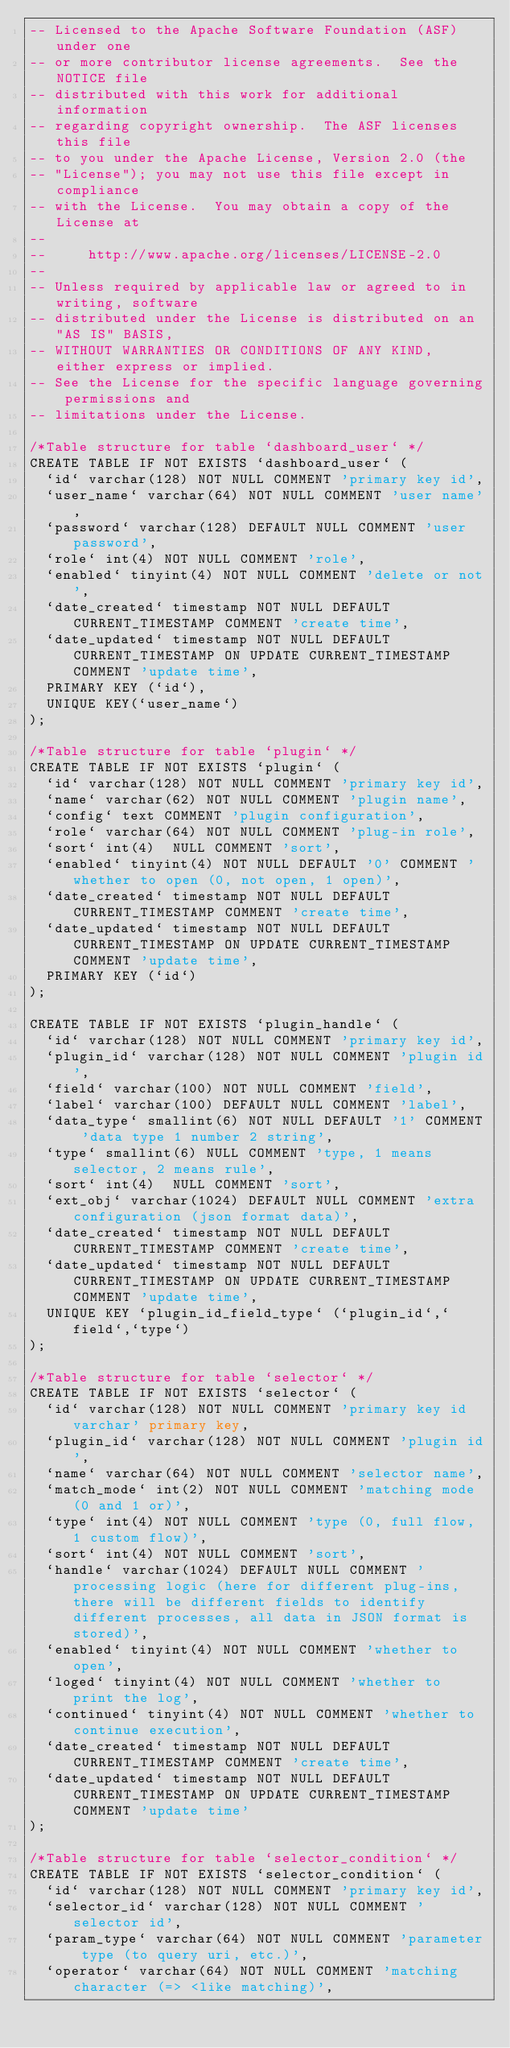Convert code to text. <code><loc_0><loc_0><loc_500><loc_500><_SQL_>-- Licensed to the Apache Software Foundation (ASF) under one
-- or more contributor license agreements.  See the NOTICE file
-- distributed with this work for additional information
-- regarding copyright ownership.  The ASF licenses this file
-- to you under the Apache License, Version 2.0 (the
-- "License"); you may not use this file except in compliance
-- with the License.  You may obtain a copy of the License at
--
--     http://www.apache.org/licenses/LICENSE-2.0
--
-- Unless required by applicable law or agreed to in writing, software
-- distributed under the License is distributed on an "AS IS" BASIS,
-- WITHOUT WARRANTIES OR CONDITIONS OF ANY KIND, either express or implied.
-- See the License for the specific language governing permissions and
-- limitations under the License.

/*Table structure for table `dashboard_user` */
CREATE TABLE IF NOT EXISTS `dashboard_user` (
  `id` varchar(128) NOT NULL COMMENT 'primary key id',
  `user_name` varchar(64) NOT NULL COMMENT 'user name',
  `password` varchar(128) DEFAULT NULL COMMENT 'user password',
  `role` int(4) NOT NULL COMMENT 'role',
  `enabled` tinyint(4) NOT NULL COMMENT 'delete or not',
  `date_created` timestamp NOT NULL DEFAULT CURRENT_TIMESTAMP COMMENT 'create time',
  `date_updated` timestamp NOT NULL DEFAULT CURRENT_TIMESTAMP ON UPDATE CURRENT_TIMESTAMP COMMENT 'update time',
  PRIMARY KEY (`id`),
  UNIQUE KEY(`user_name`)
);

/*Table structure for table `plugin` */
CREATE TABLE IF NOT EXISTS `plugin` (
  `id` varchar(128) NOT NULL COMMENT 'primary key id',
  `name` varchar(62) NOT NULL COMMENT 'plugin name',
  `config` text COMMENT 'plugin configuration',
  `role` varchar(64) NOT NULL COMMENT 'plug-in role',
  `sort` int(4)  NULL COMMENT 'sort',
  `enabled` tinyint(4) NOT NULL DEFAULT '0' COMMENT 'whether to open (0, not open, 1 open)',
  `date_created` timestamp NOT NULL DEFAULT CURRENT_TIMESTAMP COMMENT 'create time',
  `date_updated` timestamp NOT NULL DEFAULT CURRENT_TIMESTAMP ON UPDATE CURRENT_TIMESTAMP COMMENT 'update time',
  PRIMARY KEY (`id`)
);

CREATE TABLE IF NOT EXISTS `plugin_handle` (
  `id` varchar(128) NOT NULL COMMENT 'primary key id',
  `plugin_id` varchar(128) NOT NULL COMMENT 'plugin id',
  `field` varchar(100) NOT NULL COMMENT 'field',
  `label` varchar(100) DEFAULT NULL COMMENT 'label',
  `data_type` smallint(6) NOT NULL DEFAULT '1' COMMENT 'data type 1 number 2 string',
  `type` smallint(6) NULL COMMENT 'type, 1 means selector, 2 means rule',
  `sort` int(4)  NULL COMMENT 'sort',
  `ext_obj` varchar(1024) DEFAULT NULL COMMENT 'extra configuration (json format data)',
  `date_created` timestamp NOT NULL DEFAULT CURRENT_TIMESTAMP COMMENT 'create time',
  `date_updated` timestamp NOT NULL DEFAULT CURRENT_TIMESTAMP ON UPDATE CURRENT_TIMESTAMP COMMENT 'update time',
  UNIQUE KEY `plugin_id_field_type` (`plugin_id`,`field`,`type`)
);

/*Table structure for table `selector` */
CREATE TABLE IF NOT EXISTS `selector` (
  `id` varchar(128) NOT NULL COMMENT 'primary key id varchar' primary key,
  `plugin_id` varchar(128) NOT NULL COMMENT 'plugin id',
  `name` varchar(64) NOT NULL COMMENT 'selector name',
  `match_mode` int(2) NOT NULL COMMENT 'matching mode (0 and 1 or)',
  `type` int(4) NOT NULL COMMENT 'type (0, full flow, 1 custom flow)',
  `sort` int(4) NOT NULL COMMENT 'sort',
  `handle` varchar(1024) DEFAULT NULL COMMENT 'processing logic (here for different plug-ins, there will be different fields to identify different processes, all data in JSON format is stored)',
  `enabled` tinyint(4) NOT NULL COMMENT 'whether to open',
  `loged` tinyint(4) NOT NULL COMMENT 'whether to print the log',
  `continued` tinyint(4) NOT NULL COMMENT 'whether to continue execution',
  `date_created` timestamp NOT NULL DEFAULT CURRENT_TIMESTAMP COMMENT 'create time',
  `date_updated` timestamp NOT NULL DEFAULT CURRENT_TIMESTAMP ON UPDATE CURRENT_TIMESTAMP COMMENT 'update time'
);

/*Table structure for table `selector_condition` */
CREATE TABLE IF NOT EXISTS `selector_condition` (
  `id` varchar(128) NOT NULL COMMENT 'primary key id',
  `selector_id` varchar(128) NOT NULL COMMENT 'selector id',
  `param_type` varchar(64) NOT NULL COMMENT 'parameter type (to query uri, etc.)',
  `operator` varchar(64) NOT NULL COMMENT 'matching character (=> <like matching)',</code> 